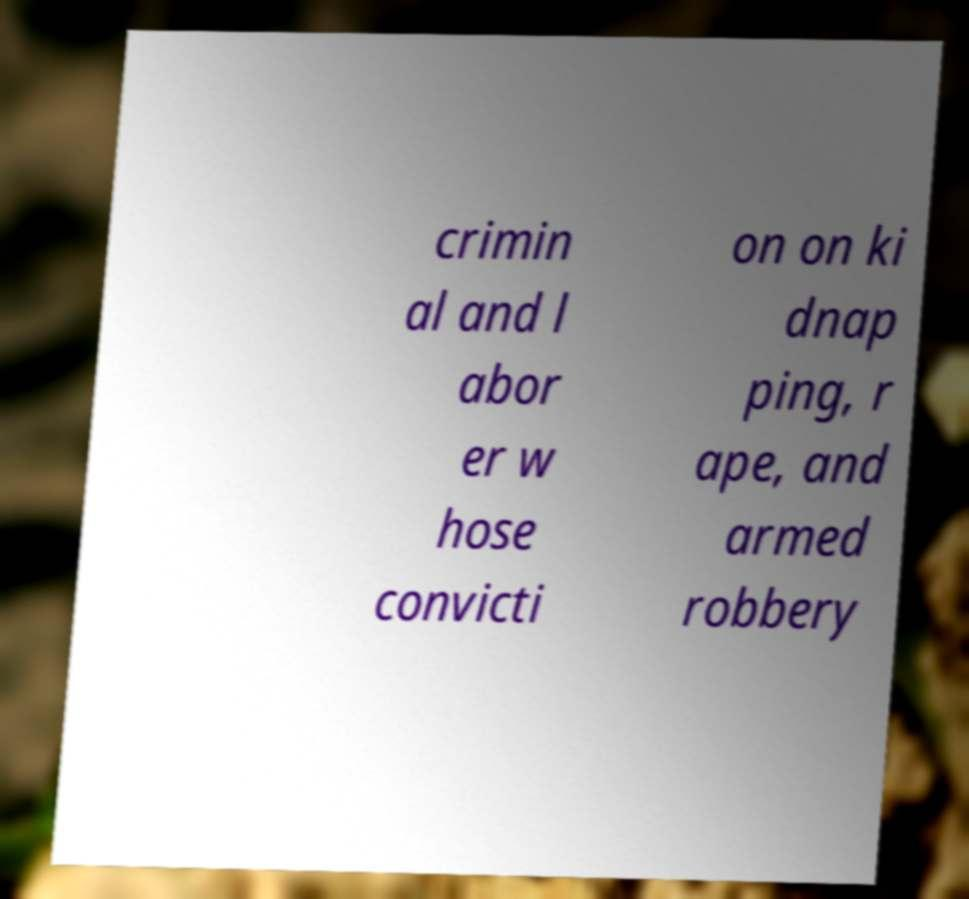For documentation purposes, I need the text within this image transcribed. Could you provide that? crimin al and l abor er w hose convicti on on ki dnap ping, r ape, and armed robbery 